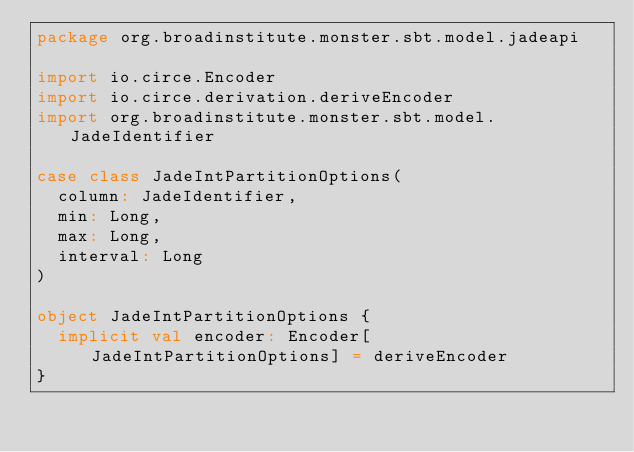<code> <loc_0><loc_0><loc_500><loc_500><_Scala_>package org.broadinstitute.monster.sbt.model.jadeapi

import io.circe.Encoder
import io.circe.derivation.deriveEncoder
import org.broadinstitute.monster.sbt.model.JadeIdentifier

case class JadeIntPartitionOptions(
  column: JadeIdentifier,
  min: Long,
  max: Long,
  interval: Long
)

object JadeIntPartitionOptions {
  implicit val encoder: Encoder[JadeIntPartitionOptions] = deriveEncoder
}
</code> 